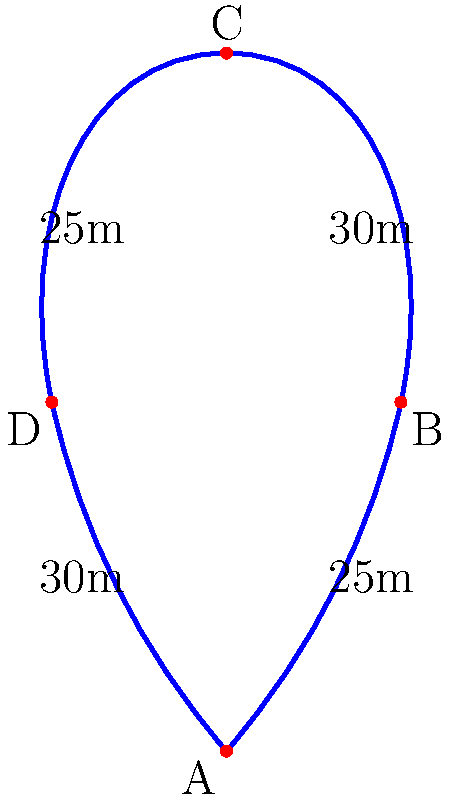In a music-themed park, there's a treble clef-shaped walking path. The path can be approximated by four straight segments forming a quadrilateral ABCD, as shown in the diagram. If AB = 25m, BC = 30m, CD = 25m, and DA = 30m, what is the perimeter of this treble clef-shaped path? To calculate the perimeter of the treble clef-shaped path, we need to sum up the lengths of all four sides of the quadrilateral ABCD. Let's break it down step by step:

1. Identify the lengths of each side:
   - AB = 25m
   - BC = 30m
   - CD = 25m
   - DA = 30m

2. Calculate the perimeter by adding all sides:
   $$\text{Perimeter} = AB + BC + CD + DA$$
   $$\text{Perimeter} = 25m + 30m + 25m + 30m$$
   $$\text{Perimeter} = 110m$$

Therefore, the perimeter of the treble clef-shaped path is 110 meters.
Answer: 110m 